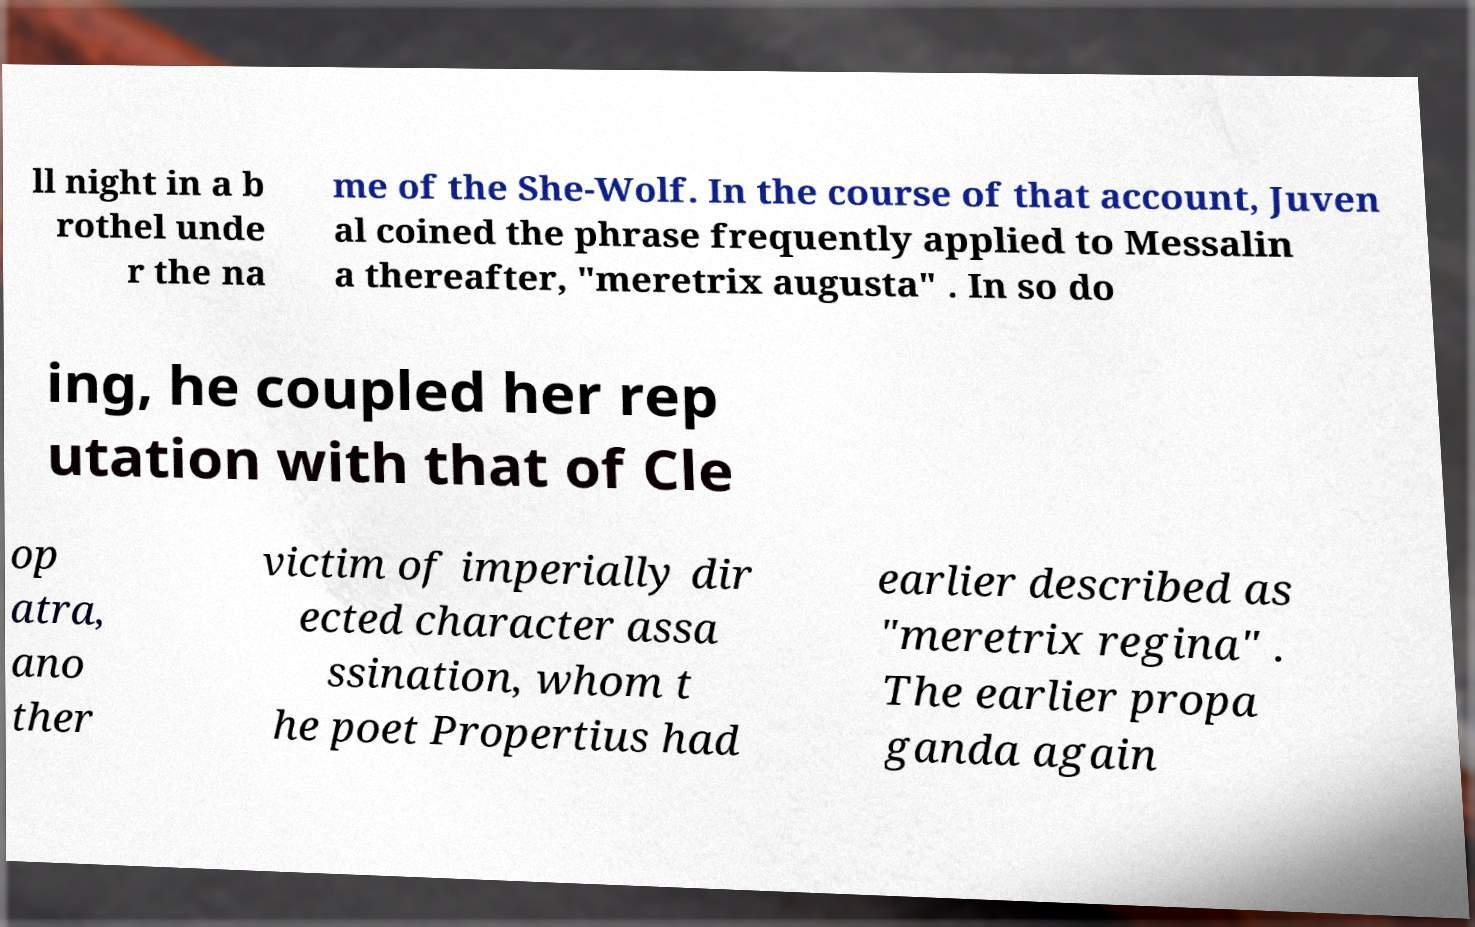Could you extract and type out the text from this image? ll night in a b rothel unde r the na me of the She-Wolf. In the course of that account, Juven al coined the phrase frequently applied to Messalin a thereafter, "meretrix augusta" . In so do ing, he coupled her rep utation with that of Cle op atra, ano ther victim of imperially dir ected character assa ssination, whom t he poet Propertius had earlier described as "meretrix regina" . The earlier propa ganda again 